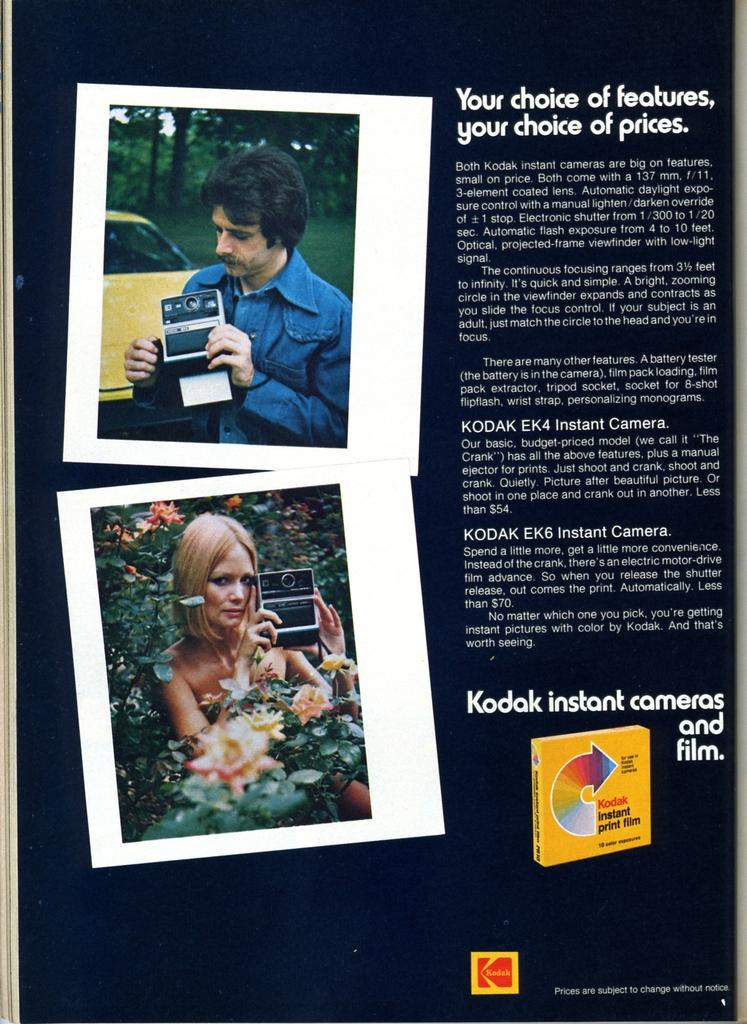What is present in the image that contains visual information? There is a poster in the image. What type of content can be found on the poster? The poster contains images and text. Can you describe the goose that is interacting with the poster in the image? There is no goose present in the image; the image only contains a poster with images and text. 